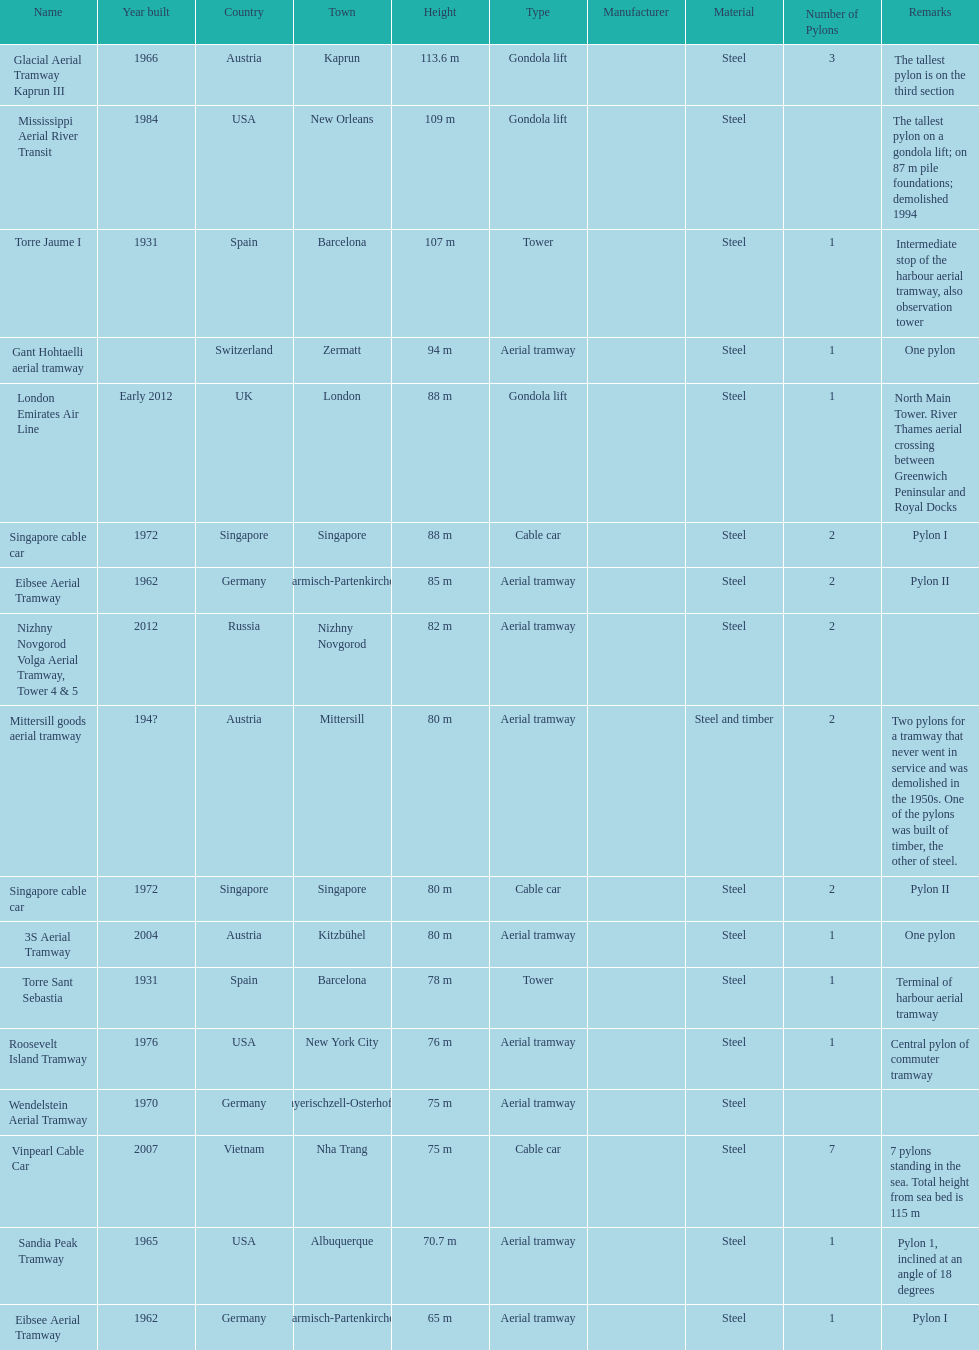How many metres is the mississippi aerial river transit from bottom to top? 109 m. 